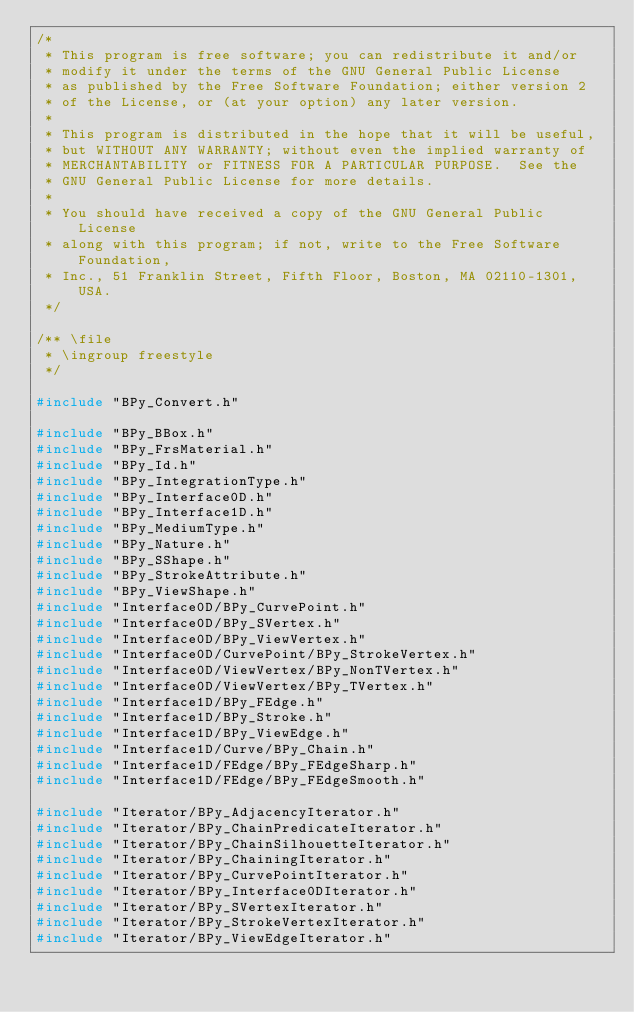Convert code to text. <code><loc_0><loc_0><loc_500><loc_500><_C++_>/*
 * This program is free software; you can redistribute it and/or
 * modify it under the terms of the GNU General Public License
 * as published by the Free Software Foundation; either version 2
 * of the License, or (at your option) any later version.
 *
 * This program is distributed in the hope that it will be useful,
 * but WITHOUT ANY WARRANTY; without even the implied warranty of
 * MERCHANTABILITY or FITNESS FOR A PARTICULAR PURPOSE.  See the
 * GNU General Public License for more details.
 *
 * You should have received a copy of the GNU General Public License
 * along with this program; if not, write to the Free Software Foundation,
 * Inc., 51 Franklin Street, Fifth Floor, Boston, MA 02110-1301, USA.
 */

/** \file
 * \ingroup freestyle
 */

#include "BPy_Convert.h"

#include "BPy_BBox.h"
#include "BPy_FrsMaterial.h"
#include "BPy_Id.h"
#include "BPy_IntegrationType.h"
#include "BPy_Interface0D.h"
#include "BPy_Interface1D.h"
#include "BPy_MediumType.h"
#include "BPy_Nature.h"
#include "BPy_SShape.h"
#include "BPy_StrokeAttribute.h"
#include "BPy_ViewShape.h"
#include "Interface0D/BPy_CurvePoint.h"
#include "Interface0D/BPy_SVertex.h"
#include "Interface0D/BPy_ViewVertex.h"
#include "Interface0D/CurvePoint/BPy_StrokeVertex.h"
#include "Interface0D/ViewVertex/BPy_NonTVertex.h"
#include "Interface0D/ViewVertex/BPy_TVertex.h"
#include "Interface1D/BPy_FEdge.h"
#include "Interface1D/BPy_Stroke.h"
#include "Interface1D/BPy_ViewEdge.h"
#include "Interface1D/Curve/BPy_Chain.h"
#include "Interface1D/FEdge/BPy_FEdgeSharp.h"
#include "Interface1D/FEdge/BPy_FEdgeSmooth.h"

#include "Iterator/BPy_AdjacencyIterator.h"
#include "Iterator/BPy_ChainPredicateIterator.h"
#include "Iterator/BPy_ChainSilhouetteIterator.h"
#include "Iterator/BPy_ChainingIterator.h"
#include "Iterator/BPy_CurvePointIterator.h"
#include "Iterator/BPy_Interface0DIterator.h"
#include "Iterator/BPy_SVertexIterator.h"
#include "Iterator/BPy_StrokeVertexIterator.h"
#include "Iterator/BPy_ViewEdgeIterator.h"</code> 